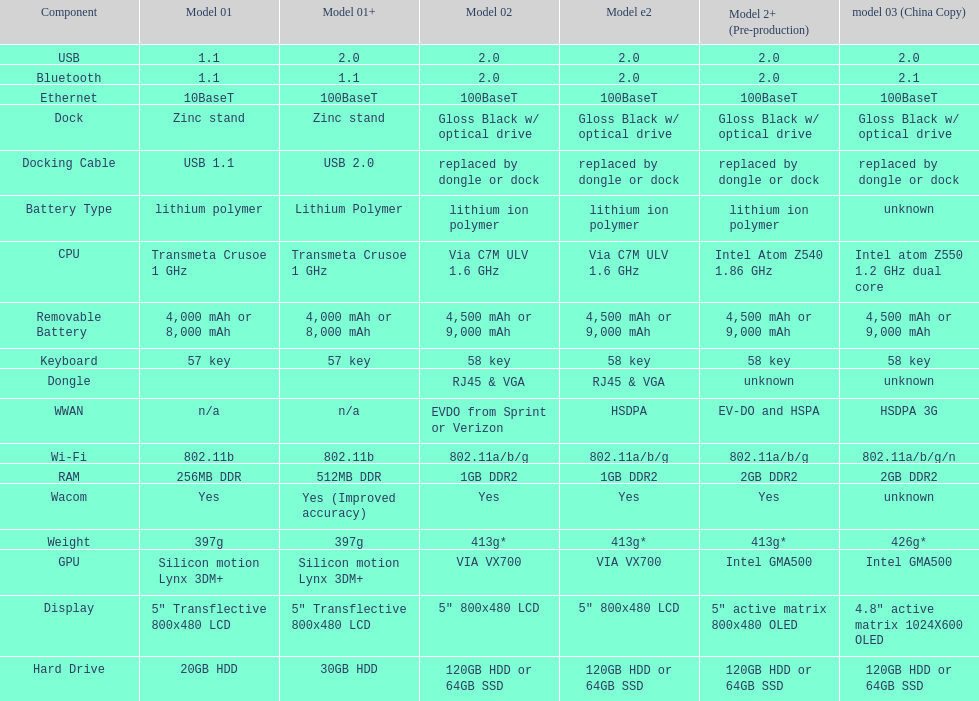What is the component before usb? Display. Parse the table in full. {'header': ['Component', 'Model 01', 'Model 01+', 'Model 02', 'Model e2', 'Model 2+ (Pre-production)', 'model 03 (China Copy)'], 'rows': [['USB', '1.1', '2.0', '2.0', '2.0', '2.0', '2.0'], ['Bluetooth', '1.1', '1.1', '2.0', '2.0', '2.0', '2.1'], ['Ethernet', '10BaseT', '100BaseT', '100BaseT', '100BaseT', '100BaseT', '100BaseT'], ['Dock', 'Zinc stand', 'Zinc stand', 'Gloss Black w/ optical drive', 'Gloss Black w/ optical drive', 'Gloss Black w/ optical drive', 'Gloss Black w/ optical drive'], ['Docking Cable', 'USB 1.1', 'USB 2.0', 'replaced by dongle or dock', 'replaced by dongle or dock', 'replaced by dongle or dock', 'replaced by dongle or dock'], ['Battery Type', 'lithium polymer', 'Lithium Polymer', 'lithium ion polymer', 'lithium ion polymer', 'lithium ion polymer', 'unknown'], ['CPU', 'Transmeta Crusoe 1\xa0GHz', 'Transmeta Crusoe 1\xa0GHz', 'Via C7M ULV 1.6\xa0GHz', 'Via C7M ULV 1.6\xa0GHz', 'Intel Atom Z540 1.86\xa0GHz', 'Intel atom Z550 1.2\xa0GHz dual core'], ['Removable Battery', '4,000 mAh or 8,000 mAh', '4,000 mAh or 8,000 mAh', '4,500 mAh or 9,000 mAh', '4,500 mAh or 9,000 mAh', '4,500 mAh or 9,000 mAh', '4,500 mAh or 9,000 mAh'], ['Keyboard', '57 key', '57 key', '58 key', '58 key', '58 key', '58 key'], ['Dongle', '', '', 'RJ45 & VGA', 'RJ45 & VGA', 'unknown', 'unknown'], ['WWAN', 'n/a', 'n/a', 'EVDO from Sprint or Verizon', 'HSDPA', 'EV-DO and HSPA', 'HSDPA 3G'], ['Wi-Fi', '802.11b', '802.11b', '802.11a/b/g', '802.11a/b/g', '802.11a/b/g', '802.11a/b/g/n'], ['RAM', '256MB DDR', '512MB DDR', '1GB DDR2', '1GB DDR2', '2GB DDR2', '2GB DDR2'], ['Wacom', 'Yes', 'Yes (Improved accuracy)', 'Yes', 'Yes', 'Yes', 'unknown'], ['Weight', '397g', '397g', '413g*', '413g*', '413g*', '426g*'], ['GPU', 'Silicon motion Lynx 3DM+', 'Silicon motion Lynx 3DM+', 'VIA VX700', 'VIA VX700', 'Intel GMA500', 'Intel GMA500'], ['Display', '5" Transflective 800x480 LCD', '5" Transflective 800x480 LCD', '5" 800x480 LCD', '5" 800x480 LCD', '5" active matrix 800x480 OLED', '4.8" active matrix 1024X600 OLED'], ['Hard Drive', '20GB HDD', '30GB HDD', '120GB HDD or 64GB SSD', '120GB HDD or 64GB SSD', '120GB HDD or 64GB SSD', '120GB HDD or 64GB SSD']]} 